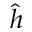<formula> <loc_0><loc_0><loc_500><loc_500>\hat { h }</formula> 